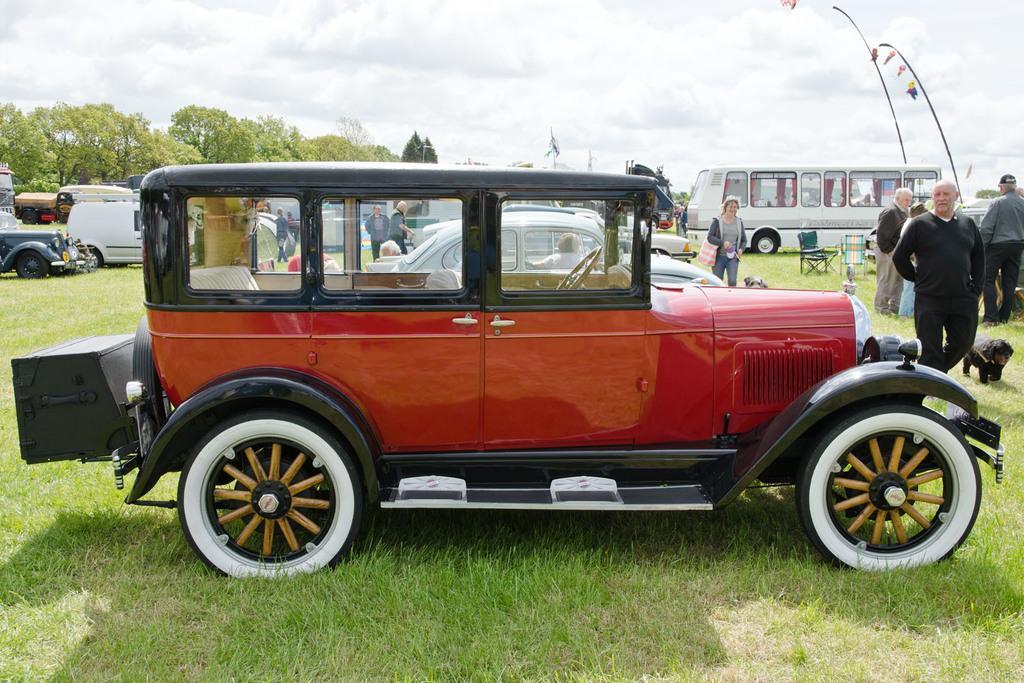Could you give a brief overview of what you see in this image? In this image I can see a car which is red, black and white in color is on the ground. I can see some grass on the ground, an animal which is black in color, few persons standing, few other vehicles, few trees which are green in color and the sky in the background. 